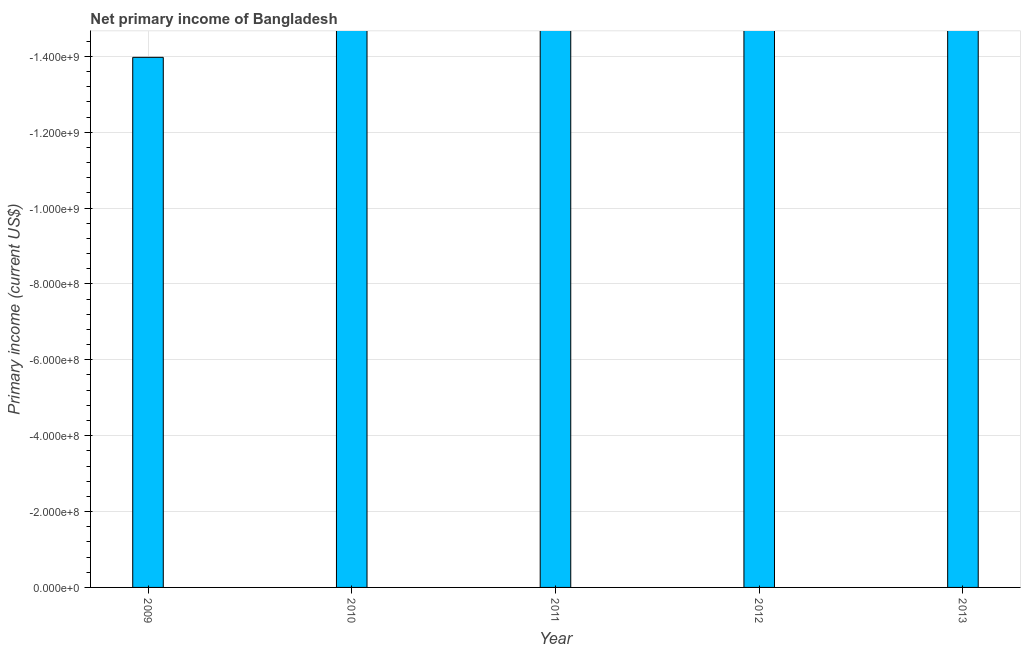Does the graph contain any zero values?
Your response must be concise. Yes. Does the graph contain grids?
Provide a succinct answer. Yes. What is the title of the graph?
Offer a terse response. Net primary income of Bangladesh. What is the label or title of the Y-axis?
Ensure brevity in your answer.  Primary income (current US$). What is the sum of the amount of primary income?
Give a very brief answer. 0. In how many years, is the amount of primary income greater than -1080000000 US$?
Ensure brevity in your answer.  0. In how many years, is the amount of primary income greater than the average amount of primary income taken over all years?
Give a very brief answer. 0. How many bars are there?
Give a very brief answer. 0. Are all the bars in the graph horizontal?
Your answer should be compact. No. How many years are there in the graph?
Make the answer very short. 5. What is the Primary income (current US$) in 2009?
Your answer should be compact. 0. What is the Primary income (current US$) in 2010?
Provide a short and direct response. 0. What is the Primary income (current US$) in 2011?
Make the answer very short. 0. What is the Primary income (current US$) of 2012?
Your answer should be very brief. 0. What is the Primary income (current US$) of 2013?
Keep it short and to the point. 0. 